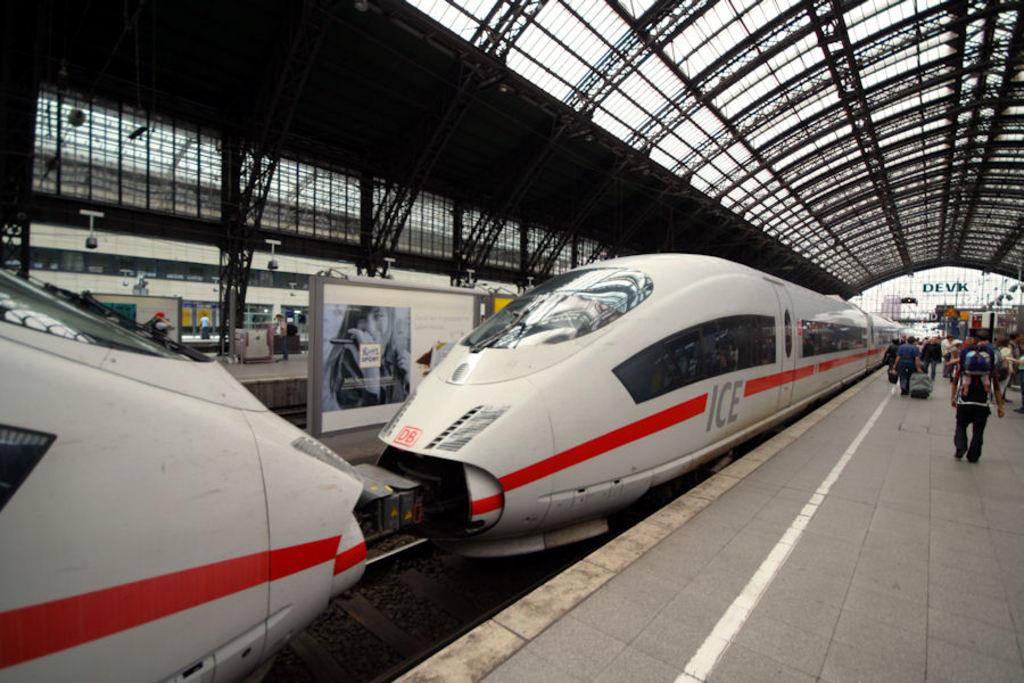What is the company that operates this train?
Offer a terse response. Ice. 